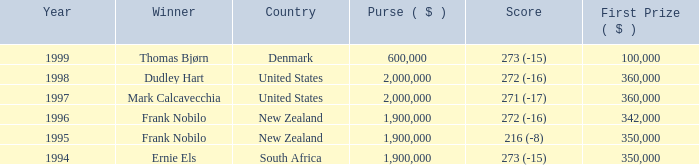What was the total purse in the years after 1996 with a score of 272 (-16) when frank nobilo won? None. 